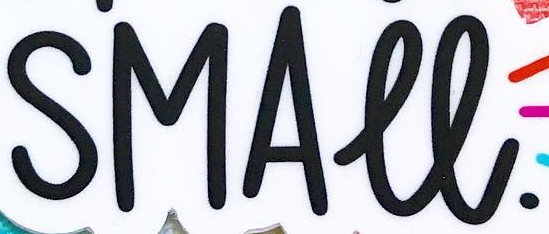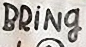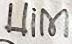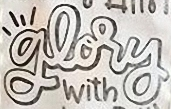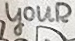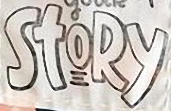Transcribe the words shown in these images in order, separated by a semicolon. SMALL.; BRİNg; Him; glory; youR; StoRy 